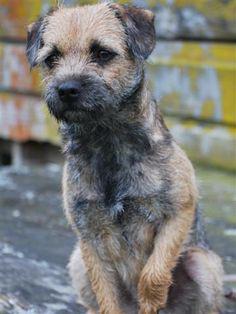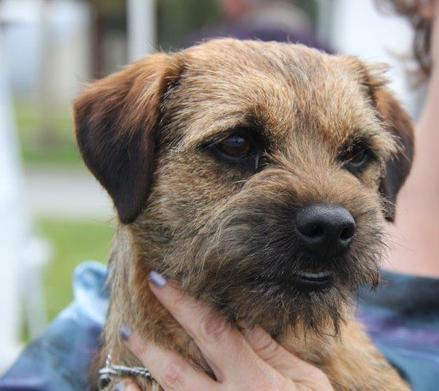The first image is the image on the left, the second image is the image on the right. For the images displayed, is the sentence "One dog is wearing a collar with a round tag clearly visible." factually correct? Answer yes or no. No. The first image is the image on the left, the second image is the image on the right. For the images shown, is this caption "There are two dogs, and one of them is lying down." true? Answer yes or no. No. 